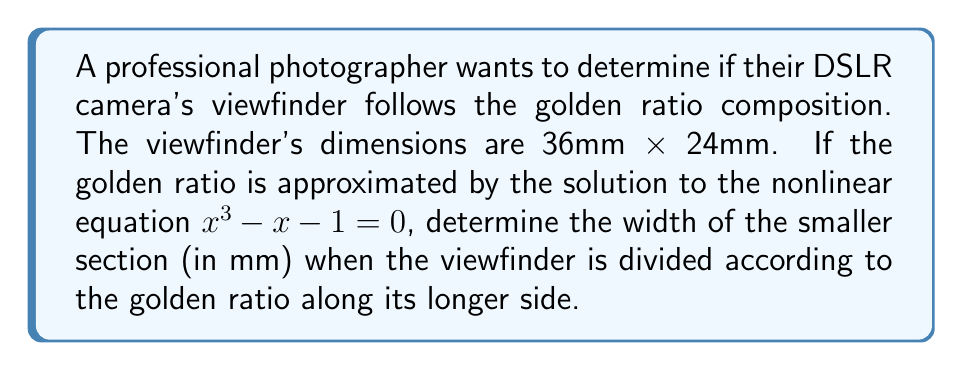Show me your answer to this math problem. 1. The golden ratio, denoted by $\phi$, is the positive solution to the equation:
   $$x^3 - x - 1 = 0$$

2. This equation can be solved numerically, but for our purposes, we'll use the approximation:
   $$\phi \approx 1.618033989$$

3. The longer side of the viewfinder is 36mm. To divide it according to the golden ratio, we need to find the length of the smaller section (x) such that:
   $$\frac{36}{x} = \phi$$

4. Rearranging this equation:
   $$x = \frac{36}{\phi}$$

5. Substituting the approximate value of $\phi$:
   $$x = \frac{36}{1.618033989}$$

6. Calculating:
   $$x \approx 22.2491mm$$

7. The smaller section of the divided viewfinder should be approximately 22.2491mm wide.
Answer: 22.2491mm 